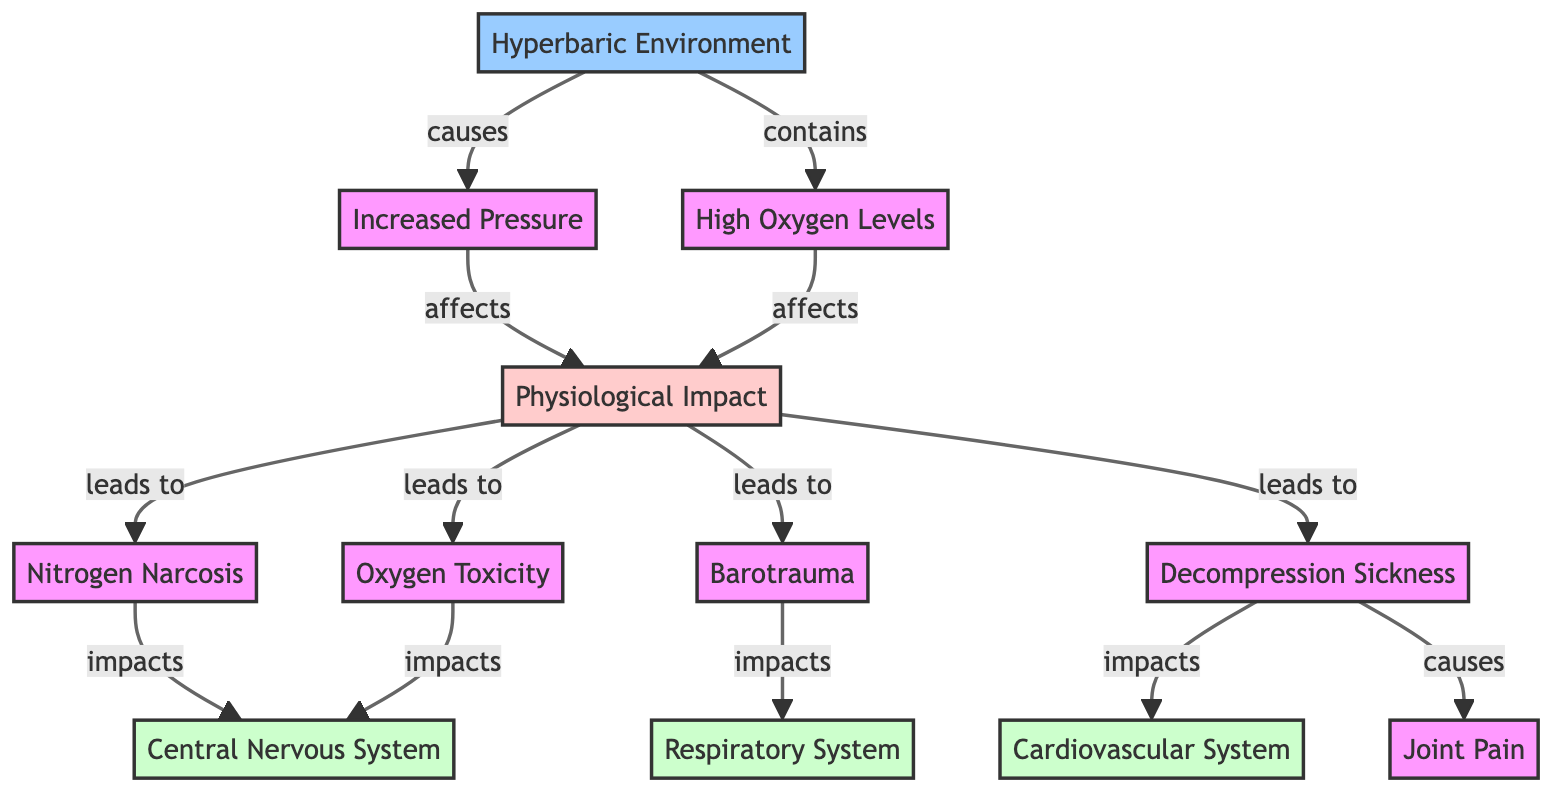What is the main environmental condition depicted in the diagram? The diagram's main focus is on the "Hyperbaric Environment," which is the foundational node in the flowchart. It is the primary factor affecting the subsequent physiological impacts.
Answer: Hyperbaric Environment How many physiological impacts are listed in the diagram? The diagram lists a total of four physiological impacts: Nitrogen Narcosis, Oxygen Toxicity, Barotrauma, and Decompression Sickness. This can be counted by identifying the distinct impacts leading from the Physiological Impact node.
Answer: 4 What does increased pressure affect according to the diagram? Increased pressure is shown in the diagram to affect "Physiological Impact." This relationship is indicated by the directed edge connecting Increased Pressure to the Physiological Impact node, outlining its influence.
Answer: Physiological Impact Which physiological impact is associated with joint pain? The physiological impact associated with joint pain is "Decompression Sickness." This is explicitly noted in the diagram, where the Decompression Sickness node is linked to Joint Pain.
Answer: Decompression Sickness Which systems are impacted by Nitrogen Narcosis? The Central Nervous System is impacted by Nitrogen Narcosis. The diagram explicitly illustrates this connection, showing the relationship from Nitrogen Narcosis to the Central Nervous System.
Answer: Central Nervous System What causes Oxygen Toxicity in deep-sea workers? Oxygen Toxicity is caused by high oxygen levels present in the hyperbaric environment. The diagram shows this causal influence through a directed edge from High Oxygen Levels to Oxygen Toxicity.
Answer: High Oxygen Levels How many systems are affected by Decompression Sickness? Decompression Sickness affects two systems: the Cardiovascular System and causes Joint Pain. This can be determined by looking at the outgoing connections from the Decompression Sickness node in the diagram.
Answer: 2 What is the relationship between Barotrauma and the Respiratory System? Barotrauma impacts the Respiratory System, as indicated by the diagram's flow from Barotrauma to the Respiratory System node. This relationship highlights the effects that barotrauma has on this specific system.
Answer: impacts How does the diagram categorize the environment and its impacts? The diagram categorizes the environment as "Hyperbaric," which leads to various physiological impacts. It visually separates environmental factors and their resulting physiological effects through color-coding and node relationships.
Answer: Hyperbaric and Physiological impacts 